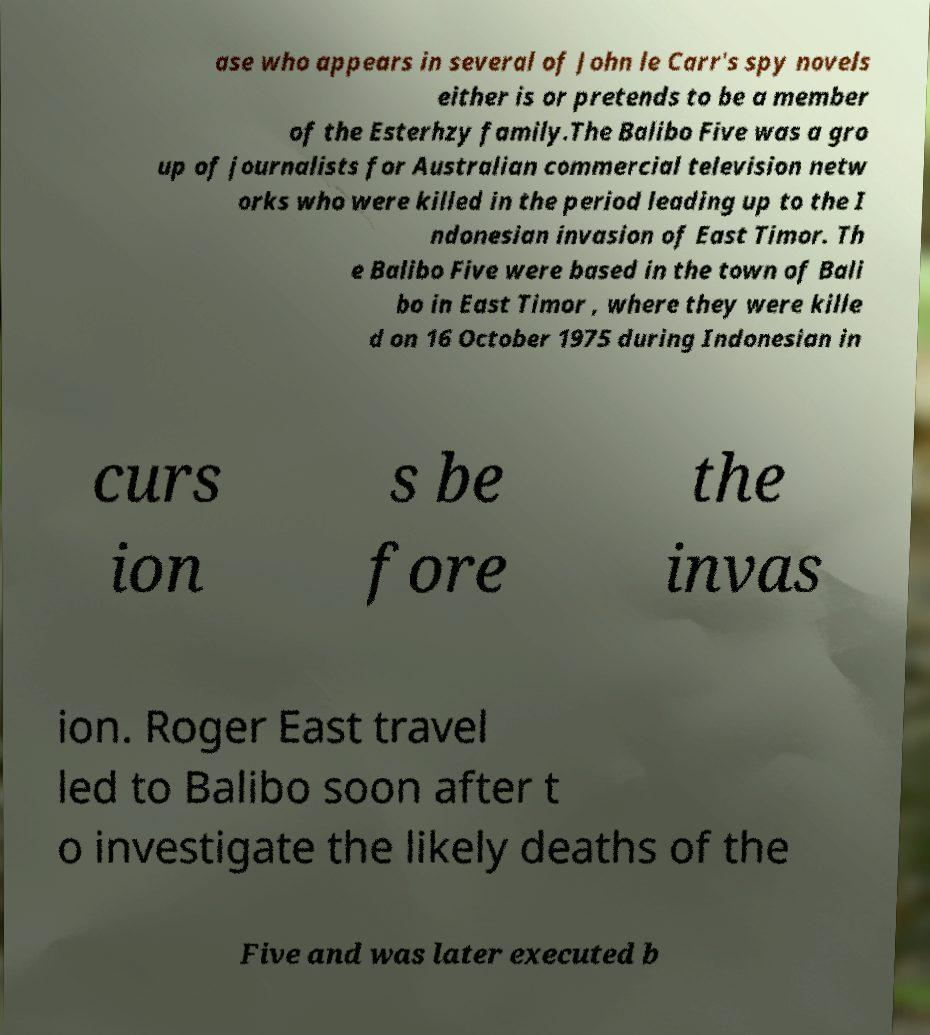Please read and relay the text visible in this image. What does it say? ase who appears in several of John le Carr's spy novels either is or pretends to be a member of the Esterhzy family.The Balibo Five was a gro up of journalists for Australian commercial television netw orks who were killed in the period leading up to the I ndonesian invasion of East Timor. Th e Balibo Five were based in the town of Bali bo in East Timor , where they were kille d on 16 October 1975 during Indonesian in curs ion s be fore the invas ion. Roger East travel led to Balibo soon after t o investigate the likely deaths of the Five and was later executed b 